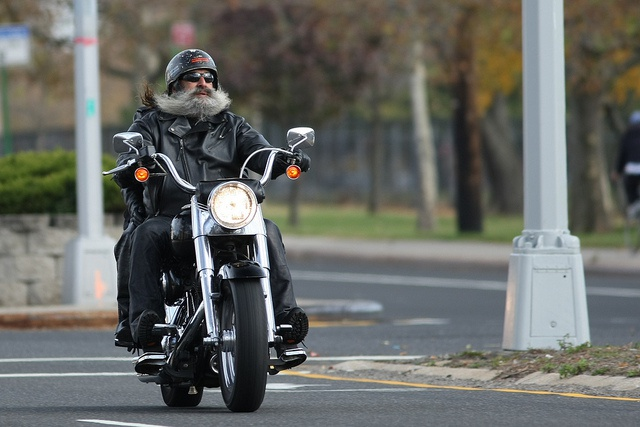Describe the objects in this image and their specific colors. I can see motorcycle in gray, black, white, and darkgray tones, people in gray, black, and darkgray tones, people in gray, black, and darkblue tones, and people in gray, black, and darkgray tones in this image. 